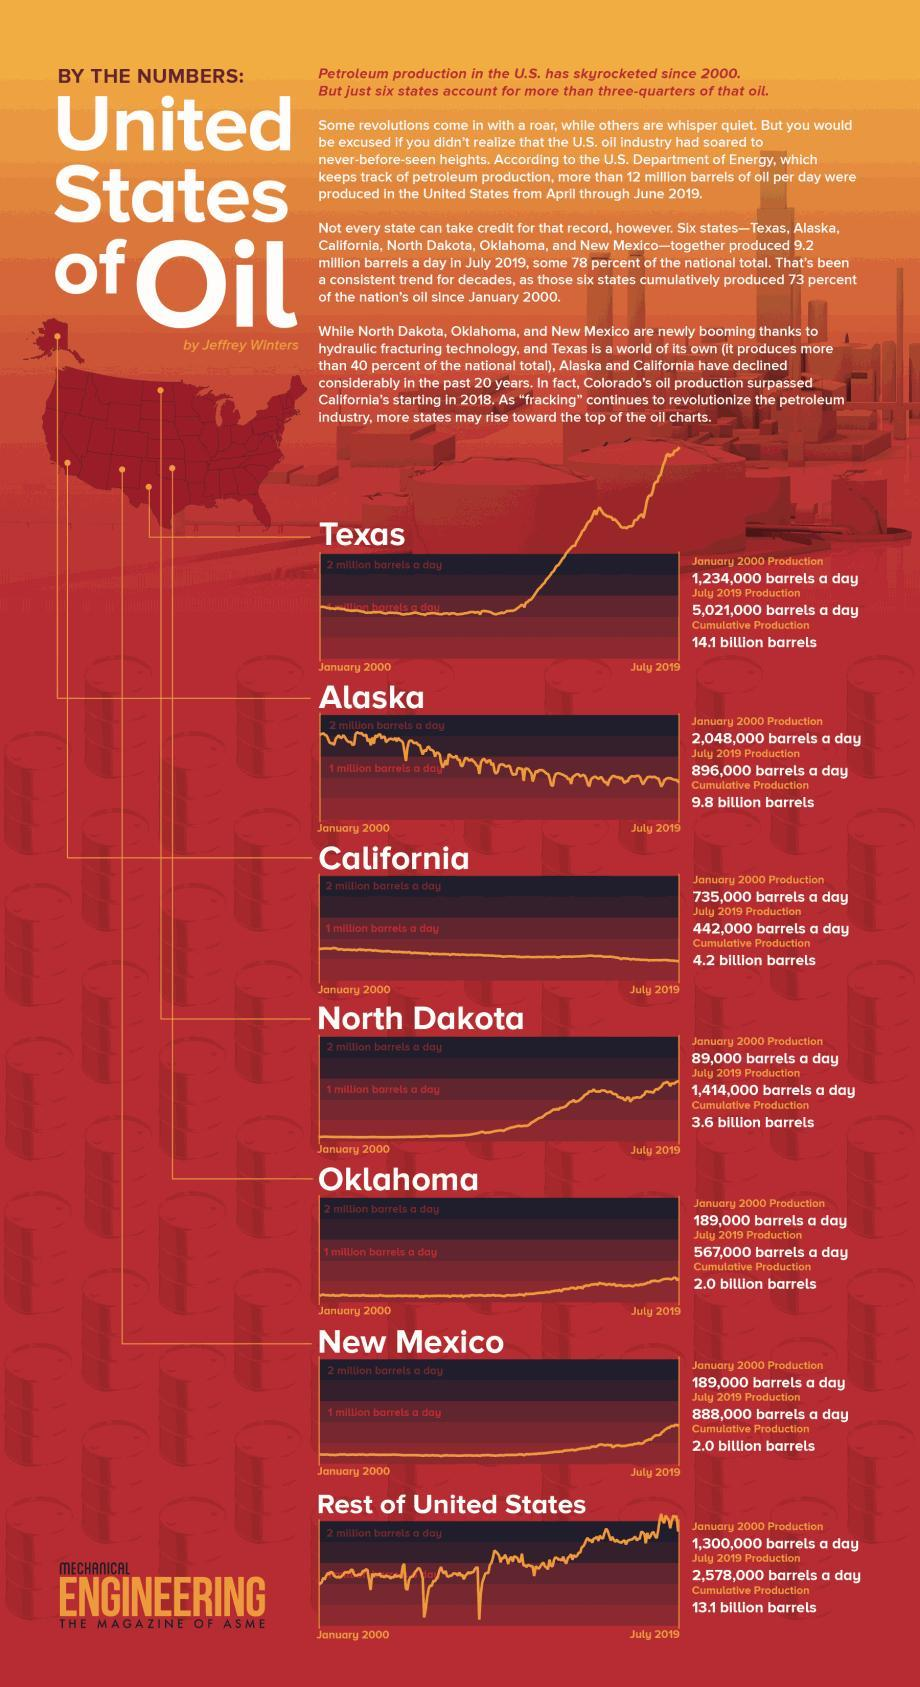What is the source of the information?
Answer the question with a short phrase. THE MAGAZINE OF ASME What was the production in January in Oklahoma? 189,000 barrels a day After rest of United States, which state had next highest cumulative production? Alaska As of 2019, what is the cumulative production of Texas? 14.1 billion barrels 